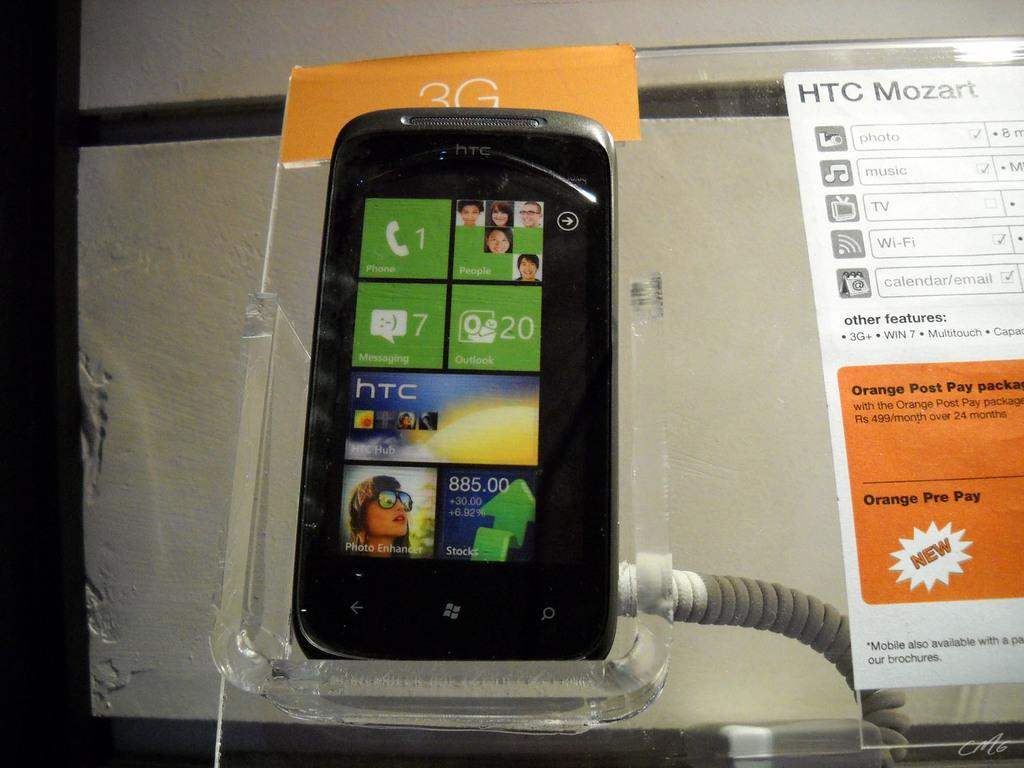<image>
Render a clear and concise summary of the photo. A 3G HTC Mozart cell phone on display with a holder on its back. 